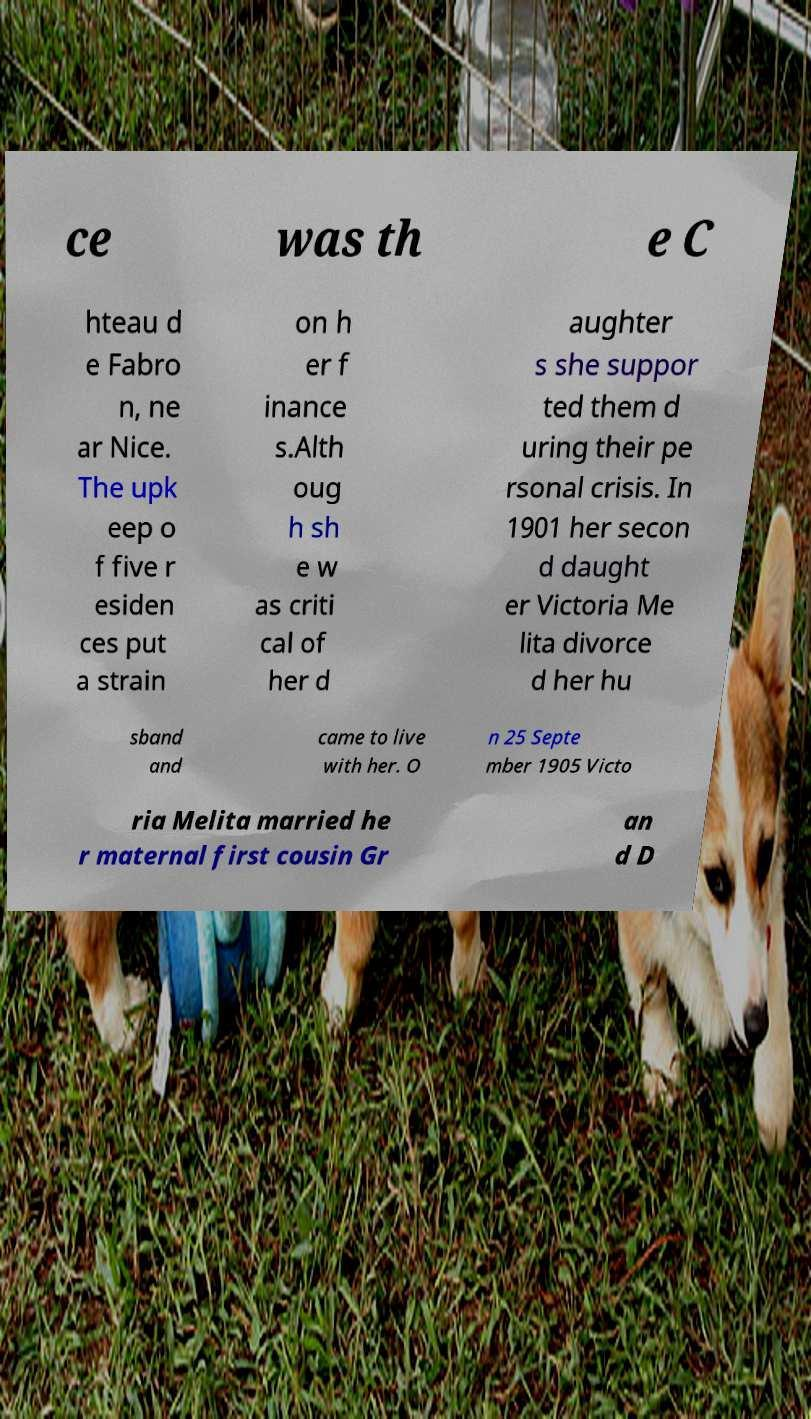Can you accurately transcribe the text from the provided image for me? ce was th e C hteau d e Fabro n, ne ar Nice. The upk eep o f five r esiden ces put a strain on h er f inance s.Alth oug h sh e w as criti cal of her d aughter s she suppor ted them d uring their pe rsonal crisis. In 1901 her secon d daught er Victoria Me lita divorce d her hu sband and came to live with her. O n 25 Septe mber 1905 Victo ria Melita married he r maternal first cousin Gr an d D 